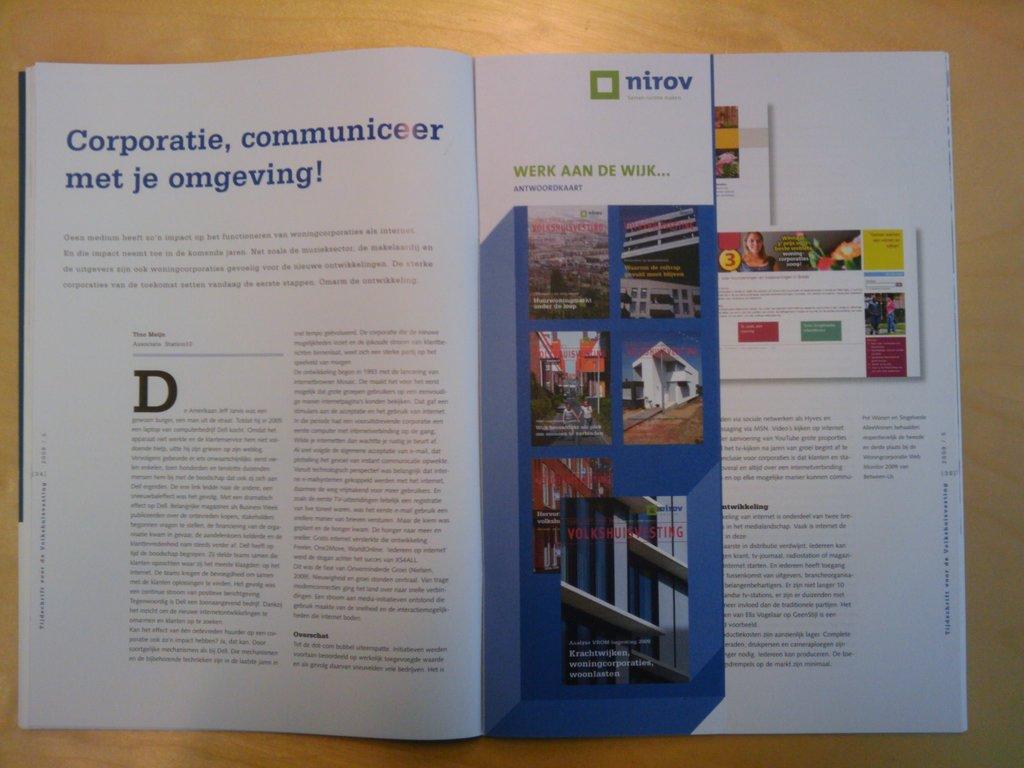What is written next to the green square?
Provide a short and direct response. Nirov. 